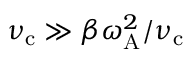<formula> <loc_0><loc_0><loc_500><loc_500>\nu _ { c } \gg \beta \omega _ { A } ^ { 2 } / \nu _ { c }</formula> 